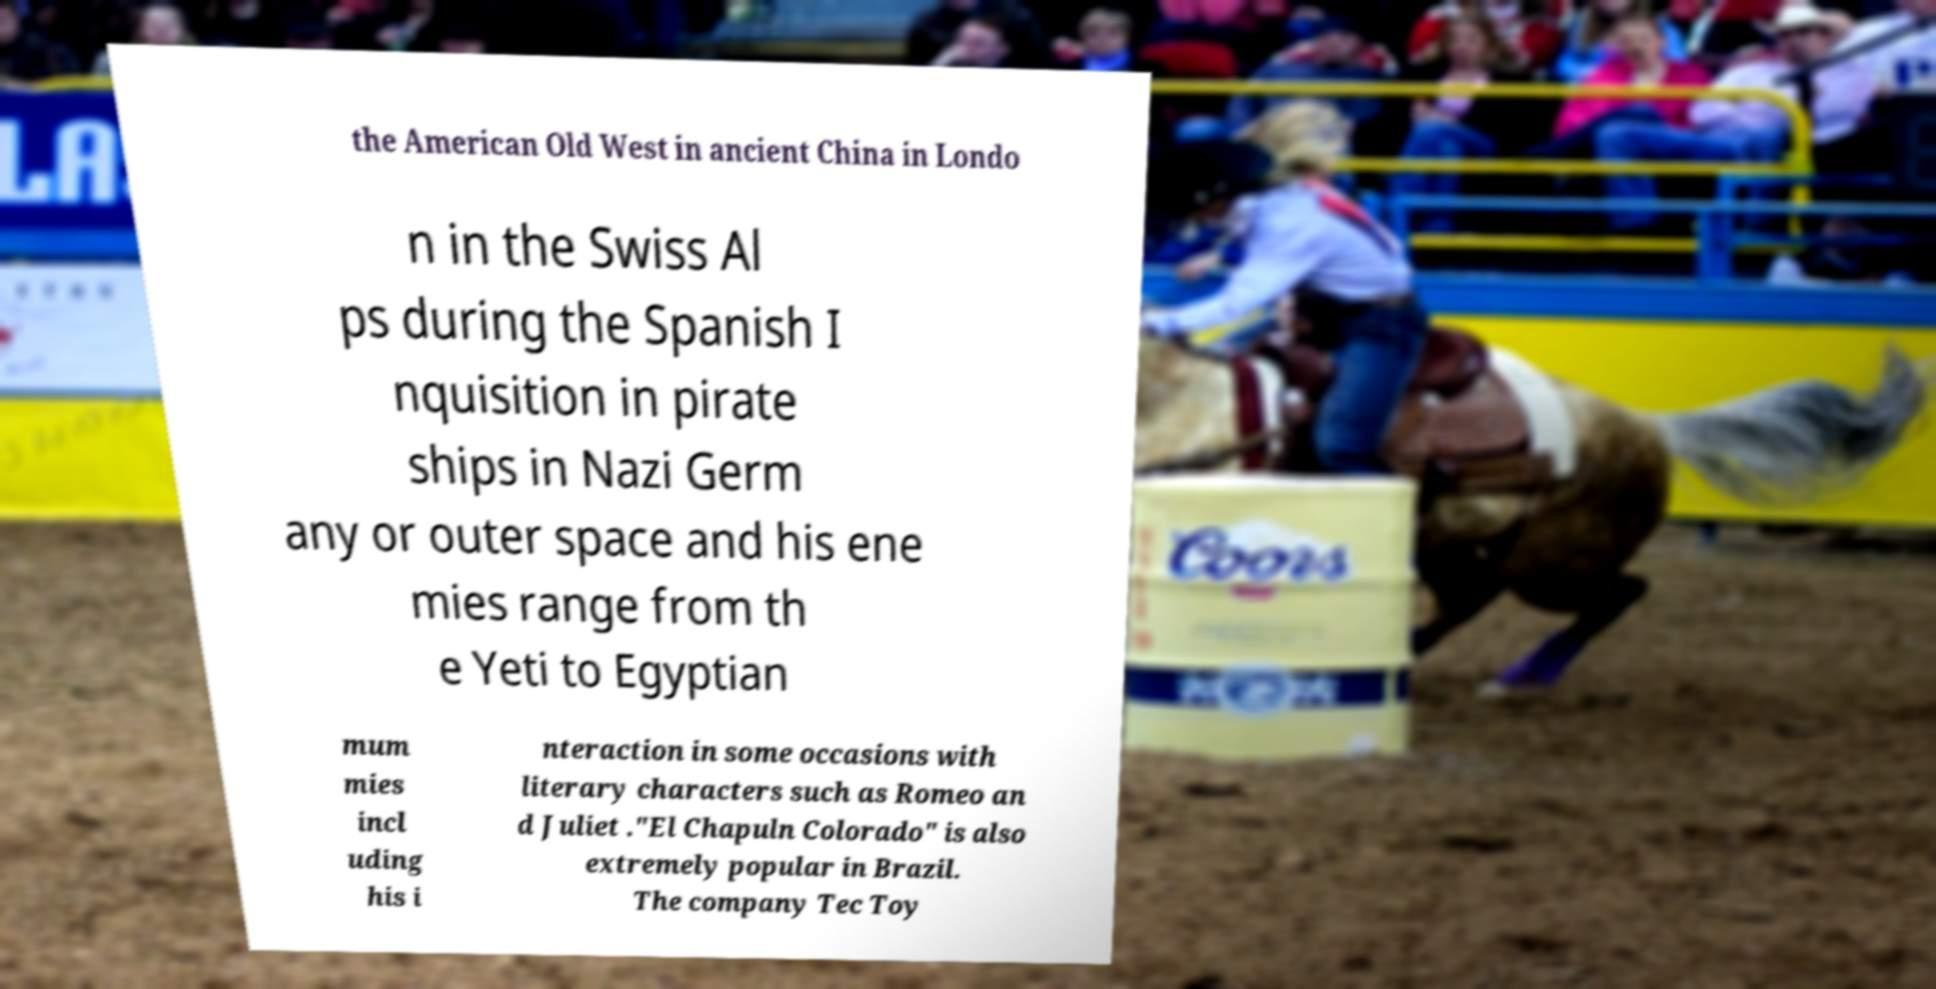There's text embedded in this image that I need extracted. Can you transcribe it verbatim? the American Old West in ancient China in Londo n in the Swiss Al ps during the Spanish I nquisition in pirate ships in Nazi Germ any or outer space and his ene mies range from th e Yeti to Egyptian mum mies incl uding his i nteraction in some occasions with literary characters such as Romeo an d Juliet ."El Chapuln Colorado" is also extremely popular in Brazil. The company Tec Toy 